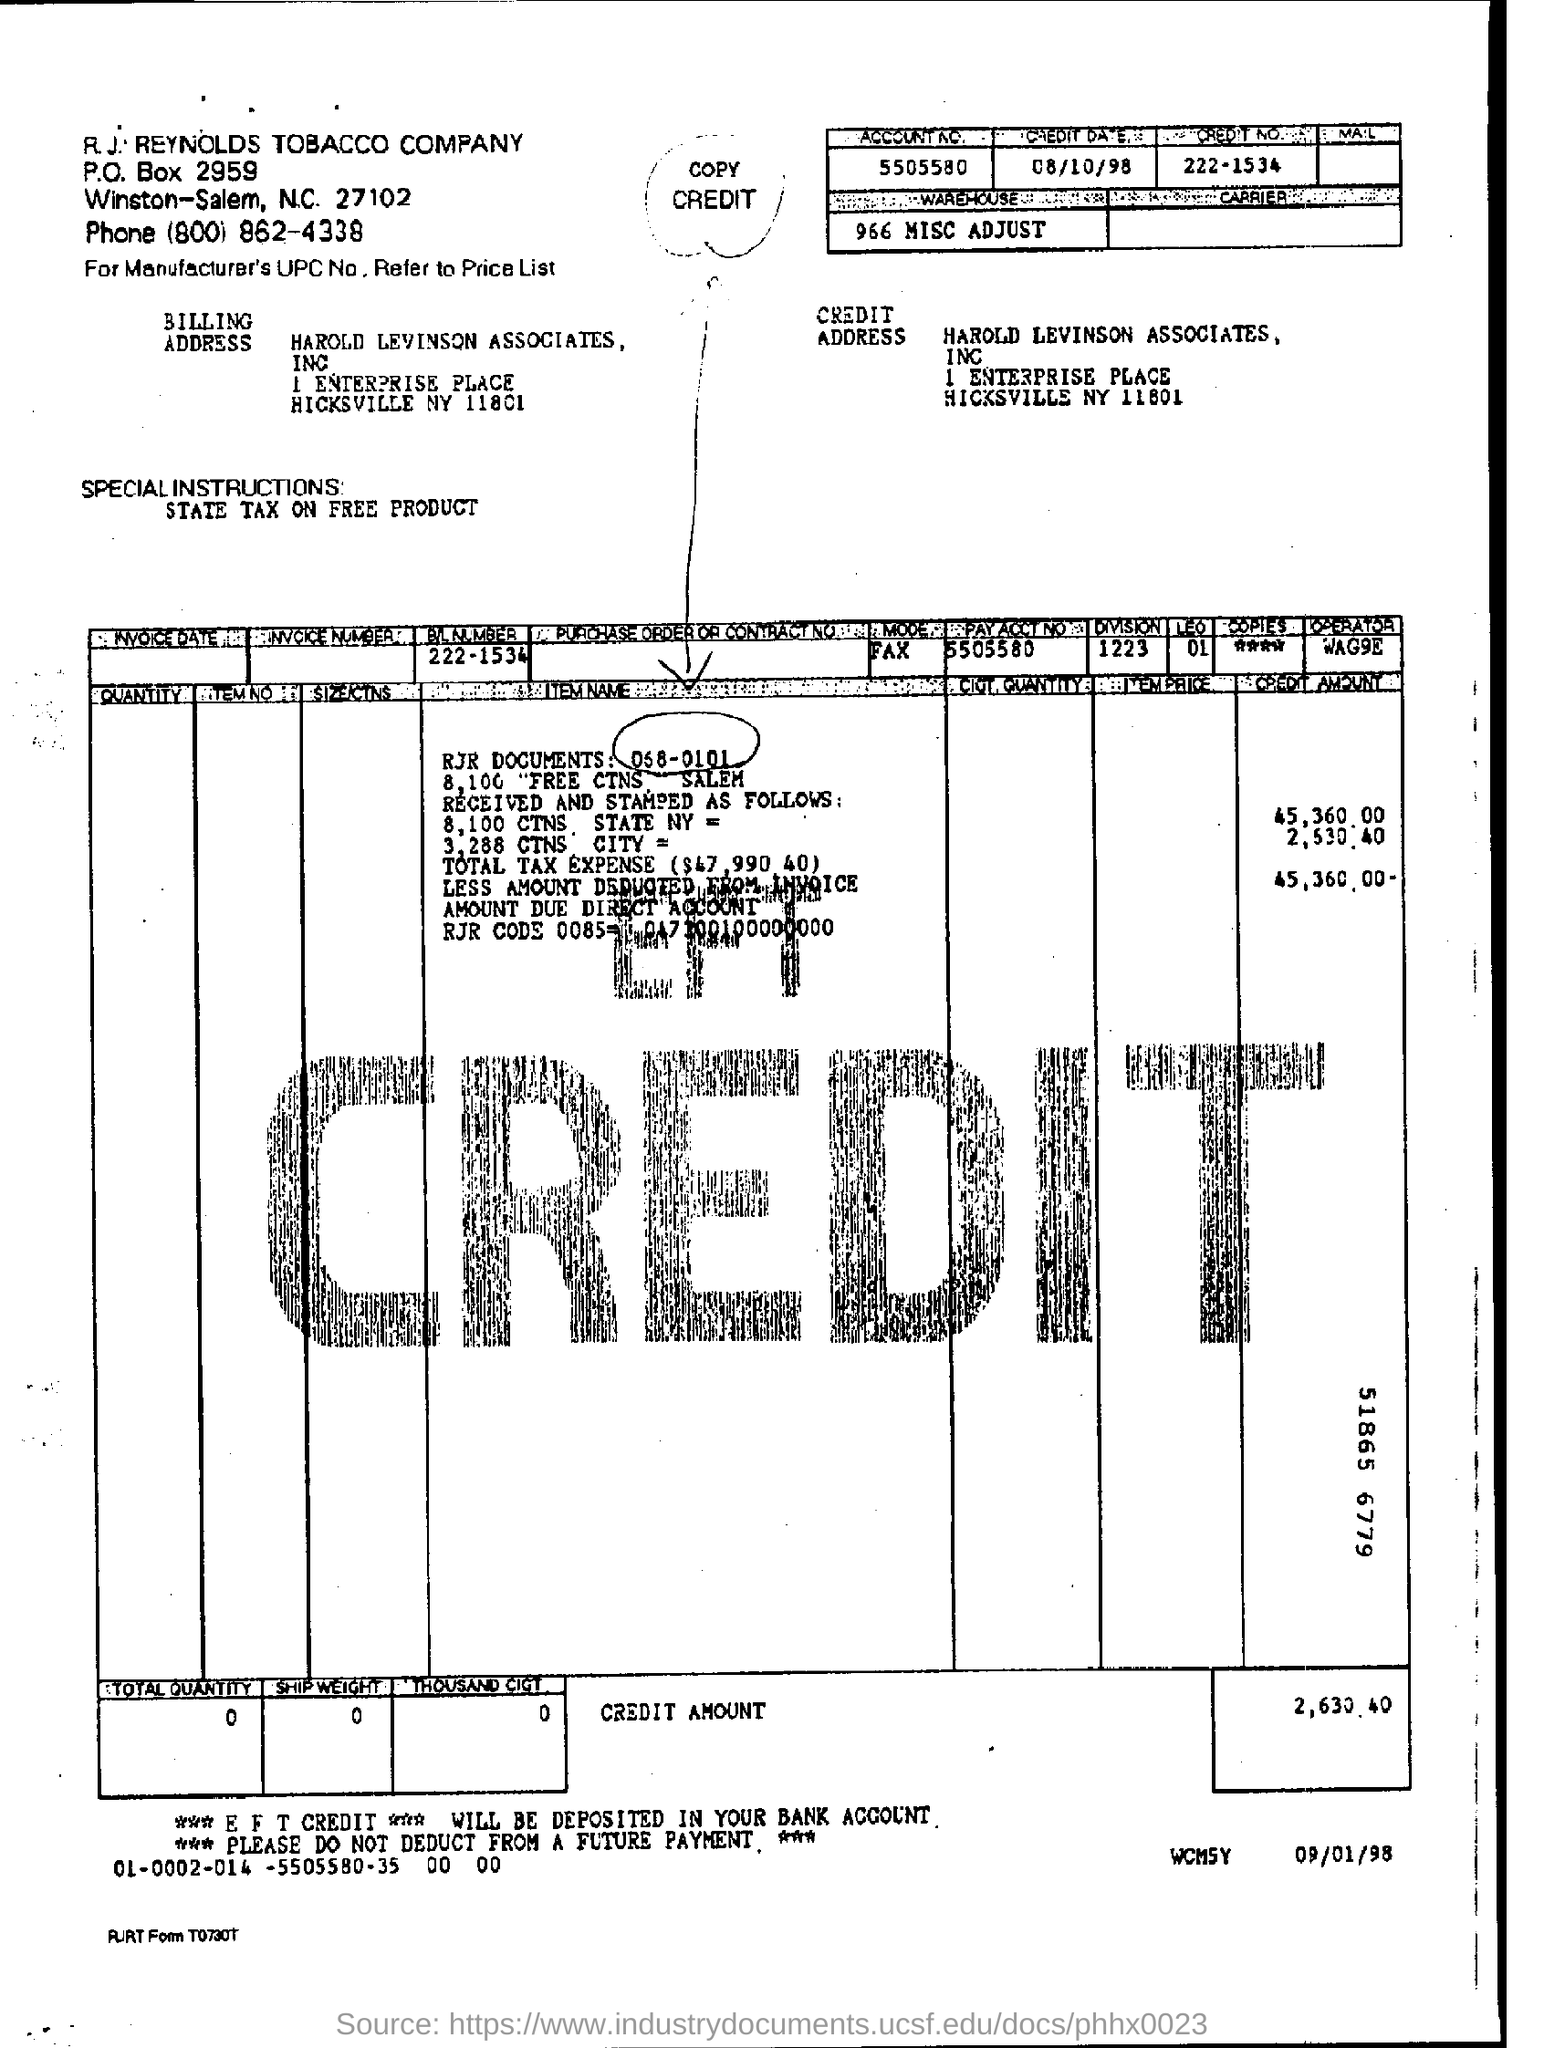Identify some key points in this picture. On October 8th, 1998, it is important to mention the credit date. The zip code for Harold Levinson Associates, Inc. is 11801. What is the account number for pay 5505580... 